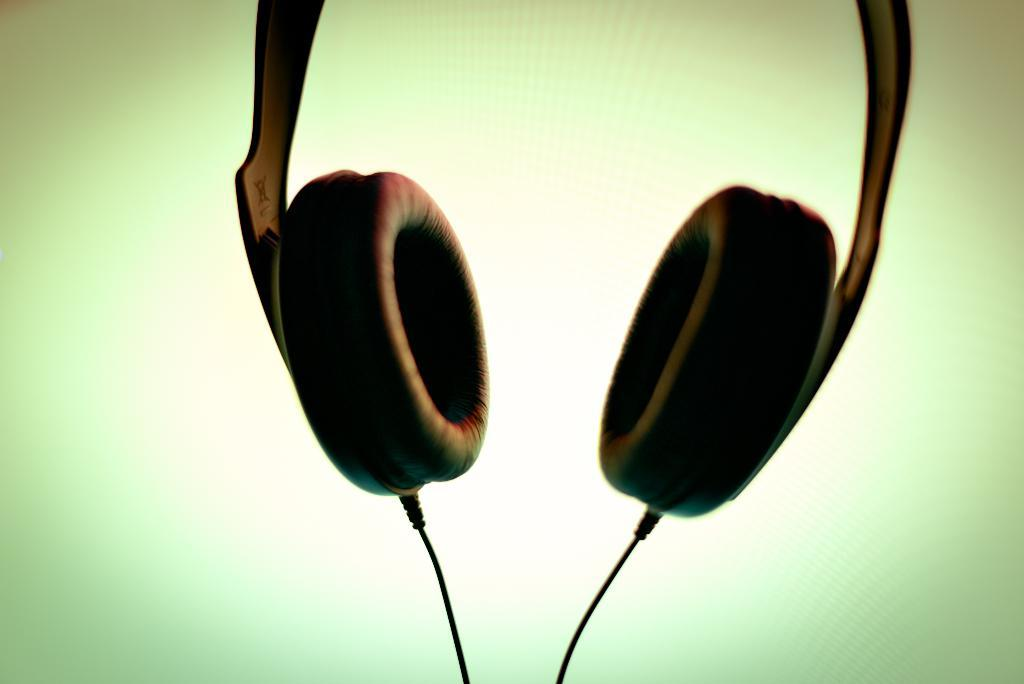What is the main object in the foreground of the image? There is a headset in the foreground of the image. How many cables are connected to the headset? There are two cables associated with the headset. Can you describe the background of the image? The background of the image is green and cream. How many eggs are being used in the rainstorm depicted in the image? There is no rainstorm or eggs present in the image; it features a headset with two cables and a green and cream background. 